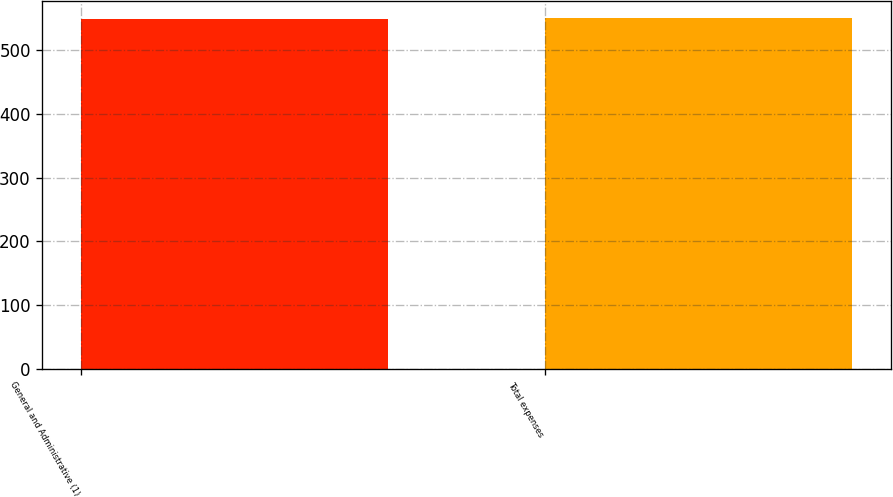Convert chart. <chart><loc_0><loc_0><loc_500><loc_500><bar_chart><fcel>General and Administrative (1)<fcel>Total expenses<nl><fcel>550<fcel>550.1<nl></chart> 